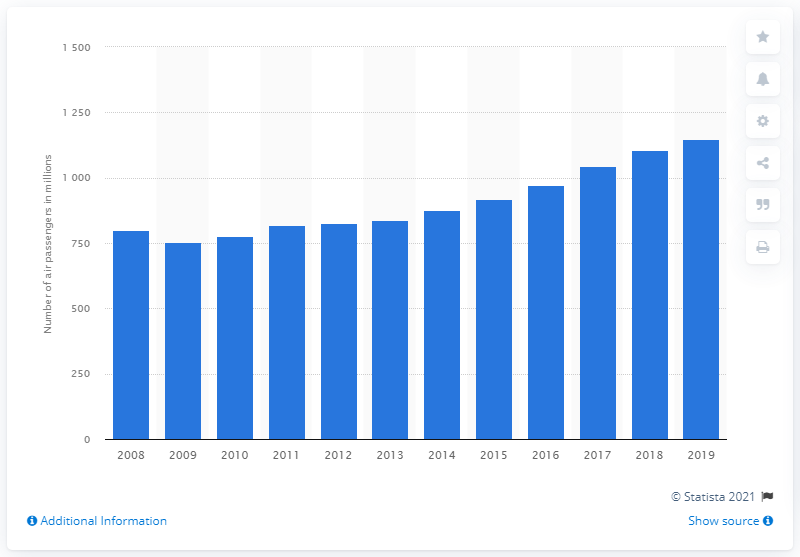Identify some key points in this picture. In 2019, a total of 1105.95 passengers were transported by air within the EU-28. 